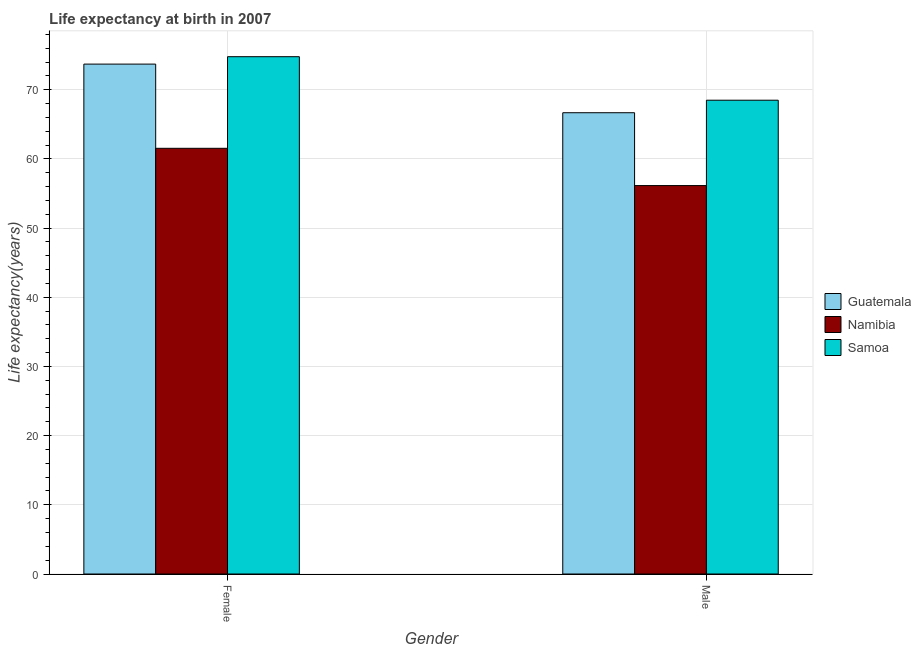How many different coloured bars are there?
Your answer should be compact. 3. Are the number of bars per tick equal to the number of legend labels?
Offer a terse response. Yes. How many bars are there on the 1st tick from the right?
Your answer should be very brief. 3. What is the label of the 2nd group of bars from the left?
Make the answer very short. Male. What is the life expectancy(male) in Samoa?
Provide a succinct answer. 68.49. Across all countries, what is the maximum life expectancy(male)?
Keep it short and to the point. 68.49. Across all countries, what is the minimum life expectancy(female)?
Your answer should be very brief. 61.54. In which country was the life expectancy(male) maximum?
Keep it short and to the point. Samoa. In which country was the life expectancy(male) minimum?
Your answer should be very brief. Namibia. What is the total life expectancy(male) in the graph?
Your response must be concise. 191.33. What is the difference between the life expectancy(male) in Samoa and that in Guatemala?
Your answer should be very brief. 1.81. What is the difference between the life expectancy(female) in Samoa and the life expectancy(male) in Namibia?
Your answer should be compact. 18.63. What is the average life expectancy(male) per country?
Ensure brevity in your answer.  63.78. What is the difference between the life expectancy(female) and life expectancy(male) in Guatemala?
Your answer should be very brief. 7.03. What is the ratio of the life expectancy(female) in Guatemala to that in Samoa?
Offer a very short reply. 0.99. What does the 1st bar from the left in Male represents?
Offer a terse response. Guatemala. What does the 2nd bar from the right in Female represents?
Your answer should be very brief. Namibia. How many countries are there in the graph?
Ensure brevity in your answer.  3. What is the difference between two consecutive major ticks on the Y-axis?
Provide a short and direct response. 10. Does the graph contain any zero values?
Offer a very short reply. No. Does the graph contain grids?
Give a very brief answer. Yes. How many legend labels are there?
Give a very brief answer. 3. What is the title of the graph?
Your answer should be very brief. Life expectancy at birth in 2007. Does "Bosnia and Herzegovina" appear as one of the legend labels in the graph?
Ensure brevity in your answer.  No. What is the label or title of the X-axis?
Your response must be concise. Gender. What is the label or title of the Y-axis?
Give a very brief answer. Life expectancy(years). What is the Life expectancy(years) in Guatemala in Female?
Ensure brevity in your answer.  73.71. What is the Life expectancy(years) of Namibia in Female?
Provide a short and direct response. 61.54. What is the Life expectancy(years) in Samoa in Female?
Provide a short and direct response. 74.78. What is the Life expectancy(years) of Guatemala in Male?
Your response must be concise. 66.68. What is the Life expectancy(years) in Namibia in Male?
Provide a short and direct response. 56.15. What is the Life expectancy(years) in Samoa in Male?
Ensure brevity in your answer.  68.49. Across all Gender, what is the maximum Life expectancy(years) in Guatemala?
Your answer should be compact. 73.71. Across all Gender, what is the maximum Life expectancy(years) of Namibia?
Your answer should be compact. 61.54. Across all Gender, what is the maximum Life expectancy(years) in Samoa?
Offer a very short reply. 74.78. Across all Gender, what is the minimum Life expectancy(years) of Guatemala?
Your answer should be compact. 66.68. Across all Gender, what is the minimum Life expectancy(years) in Namibia?
Offer a very short reply. 56.15. Across all Gender, what is the minimum Life expectancy(years) of Samoa?
Offer a very short reply. 68.49. What is the total Life expectancy(years) in Guatemala in the graph?
Make the answer very short. 140.39. What is the total Life expectancy(years) in Namibia in the graph?
Give a very brief answer. 117.69. What is the total Life expectancy(years) in Samoa in the graph?
Your response must be concise. 143.28. What is the difference between the Life expectancy(years) in Guatemala in Female and that in Male?
Provide a short and direct response. 7.03. What is the difference between the Life expectancy(years) in Namibia in Female and that in Male?
Keep it short and to the point. 5.39. What is the difference between the Life expectancy(years) of Samoa in Female and that in Male?
Your answer should be very brief. 6.29. What is the difference between the Life expectancy(years) in Guatemala in Female and the Life expectancy(years) in Namibia in Male?
Your answer should be compact. 17.56. What is the difference between the Life expectancy(years) of Guatemala in Female and the Life expectancy(years) of Samoa in Male?
Offer a terse response. 5.22. What is the difference between the Life expectancy(years) in Namibia in Female and the Life expectancy(years) in Samoa in Male?
Provide a succinct answer. -6.95. What is the average Life expectancy(years) in Guatemala per Gender?
Provide a succinct answer. 70.2. What is the average Life expectancy(years) in Namibia per Gender?
Your response must be concise. 58.85. What is the average Life expectancy(years) of Samoa per Gender?
Offer a very short reply. 71.64. What is the difference between the Life expectancy(years) of Guatemala and Life expectancy(years) of Namibia in Female?
Offer a very short reply. 12.17. What is the difference between the Life expectancy(years) of Guatemala and Life expectancy(years) of Samoa in Female?
Give a very brief answer. -1.07. What is the difference between the Life expectancy(years) of Namibia and Life expectancy(years) of Samoa in Female?
Your answer should be very brief. -13.24. What is the difference between the Life expectancy(years) in Guatemala and Life expectancy(years) in Namibia in Male?
Give a very brief answer. 10.53. What is the difference between the Life expectancy(years) in Guatemala and Life expectancy(years) in Samoa in Male?
Keep it short and to the point. -1.81. What is the difference between the Life expectancy(years) in Namibia and Life expectancy(years) in Samoa in Male?
Ensure brevity in your answer.  -12.34. What is the ratio of the Life expectancy(years) of Guatemala in Female to that in Male?
Ensure brevity in your answer.  1.11. What is the ratio of the Life expectancy(years) in Namibia in Female to that in Male?
Your answer should be very brief. 1.1. What is the ratio of the Life expectancy(years) in Samoa in Female to that in Male?
Your answer should be compact. 1.09. What is the difference between the highest and the second highest Life expectancy(years) of Guatemala?
Provide a short and direct response. 7.03. What is the difference between the highest and the second highest Life expectancy(years) of Namibia?
Ensure brevity in your answer.  5.39. What is the difference between the highest and the second highest Life expectancy(years) of Samoa?
Ensure brevity in your answer.  6.29. What is the difference between the highest and the lowest Life expectancy(years) of Guatemala?
Ensure brevity in your answer.  7.03. What is the difference between the highest and the lowest Life expectancy(years) in Namibia?
Provide a succinct answer. 5.39. What is the difference between the highest and the lowest Life expectancy(years) in Samoa?
Make the answer very short. 6.29. 